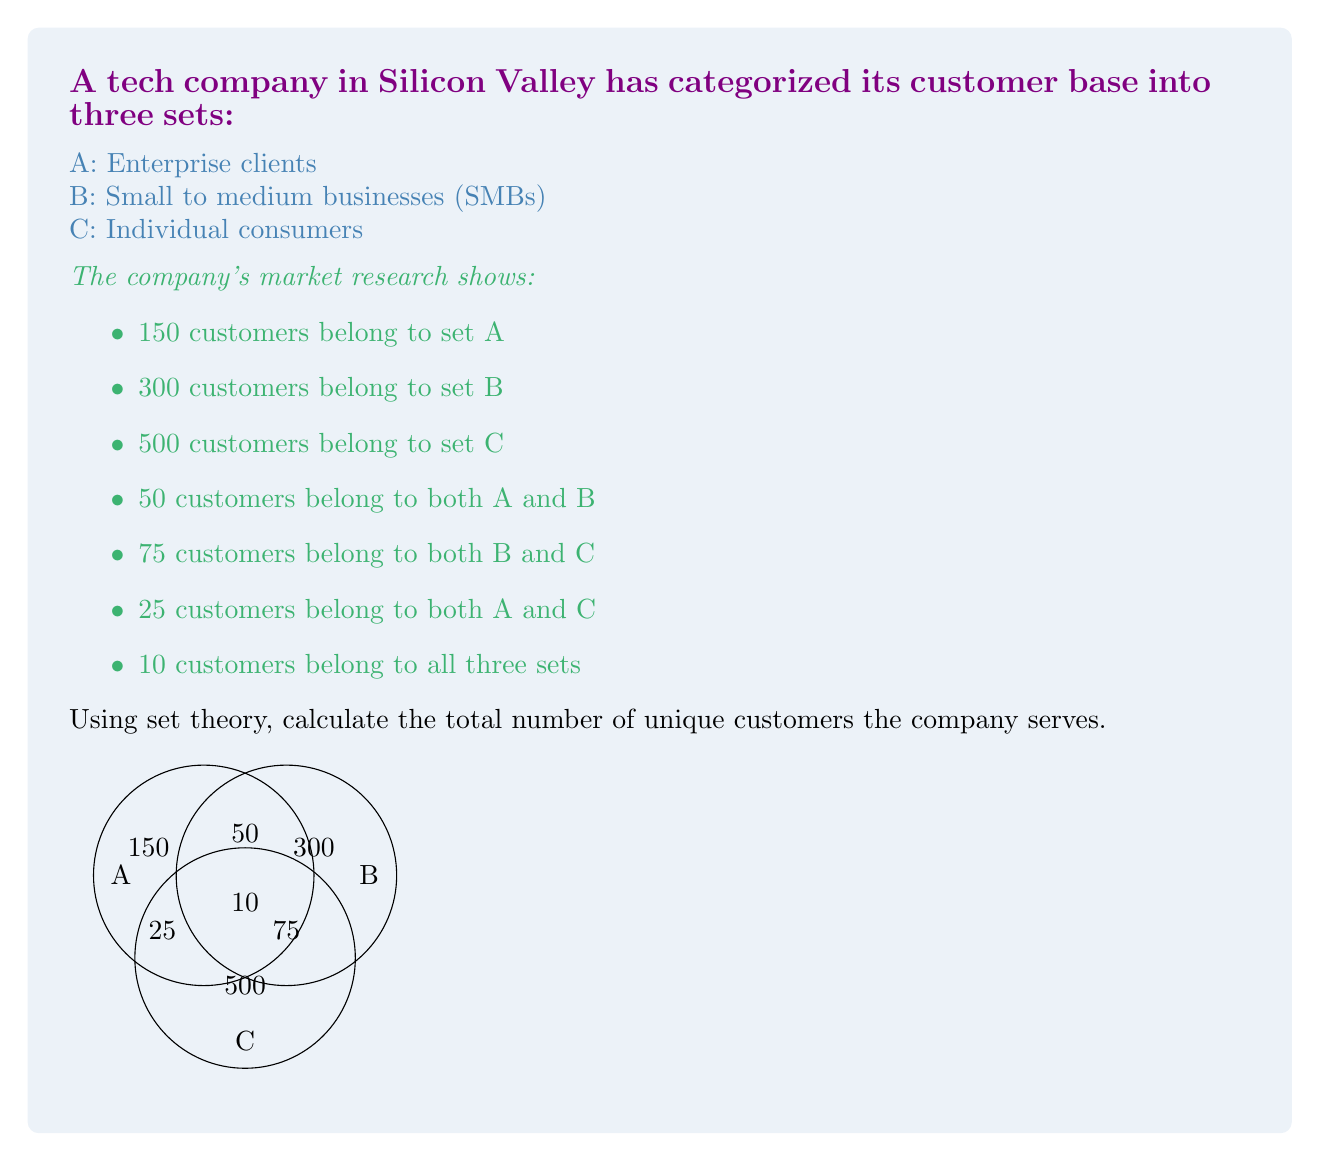Teach me how to tackle this problem. To solve this problem, we'll use the Inclusion-Exclusion Principle from set theory. This principle states that for three sets A, B, and C:

$$ |A \cup B \cup C| = |A| + |B| + |C| - |A \cap B| - |B \cap C| - |A \cap C| + |A \cap B \cap C| $$

Where:
- $|A \cup B \cup C|$ represents the total number of unique elements in all sets
- $|A|$, $|B|$, and $|C|$ are the number of elements in each set
- $|A \cap B|$, $|B \cap C|$, and $|A \cap C|$ are the number of elements in the intersections of two sets
- $|A \cap B \cap C|$ is the number of elements common to all three sets

Let's plug in the values from our problem:

1. $|A| = 150$
2. $|B| = 300$
3. $|C| = 500$
4. $|A \cap B| = 50$
5. $|B \cap C| = 75$
6. $|A \cap C| = 25$
7. $|A \cap B \cap C| = 10$

Now, let's apply the formula:

$$ |A \cup B \cup C| = 150 + 300 + 500 - 50 - 75 - 25 + 10 $$

$$ |A \cup B \cup C| = 950 - 150 + 10 $$

$$ |A \cup B \cup C| = 810 $$

Therefore, the total number of unique customers the company serves is 810.
Answer: 810 customers 